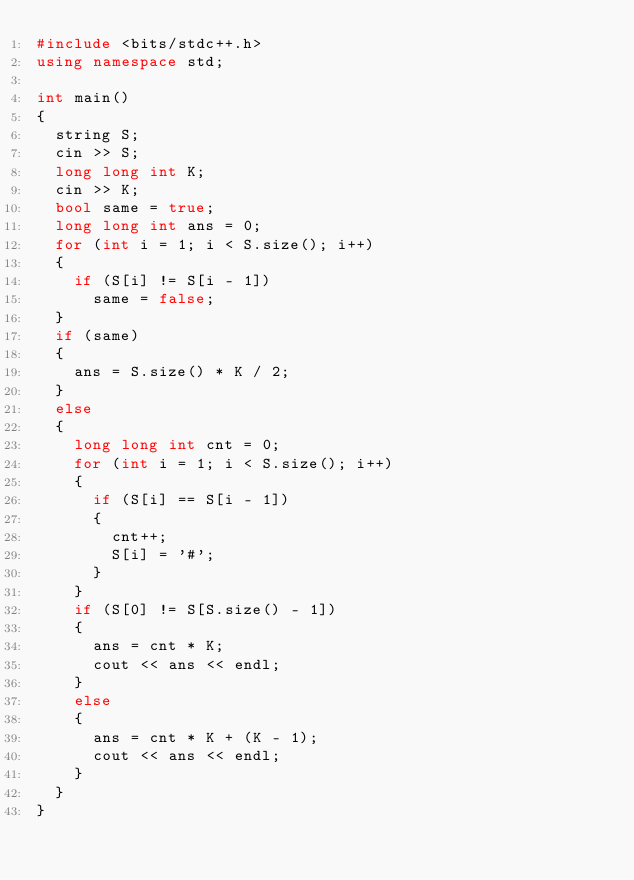Convert code to text. <code><loc_0><loc_0><loc_500><loc_500><_C++_>#include <bits/stdc++.h>
using namespace std;

int main()
{
  string S;
  cin >> S;
  long long int K;
  cin >> K;
  bool same = true;
  long long int ans = 0;
  for (int i = 1; i < S.size(); i++)
  {
    if (S[i] != S[i - 1])
      same = false;
  }
  if (same)
  {
    ans = S.size() * K / 2;
  }
  else
  {
    long long int cnt = 0;
    for (int i = 1; i < S.size(); i++)
    {
      if (S[i] == S[i - 1])
      {
        cnt++;
        S[i] = '#';
      }
    }
    if (S[0] != S[S.size() - 1])
    {
      ans = cnt * K;
      cout << ans << endl;
    }
    else
    {
      ans = cnt * K + (K - 1);
      cout << ans << endl;
    }
  }
}
</code> 